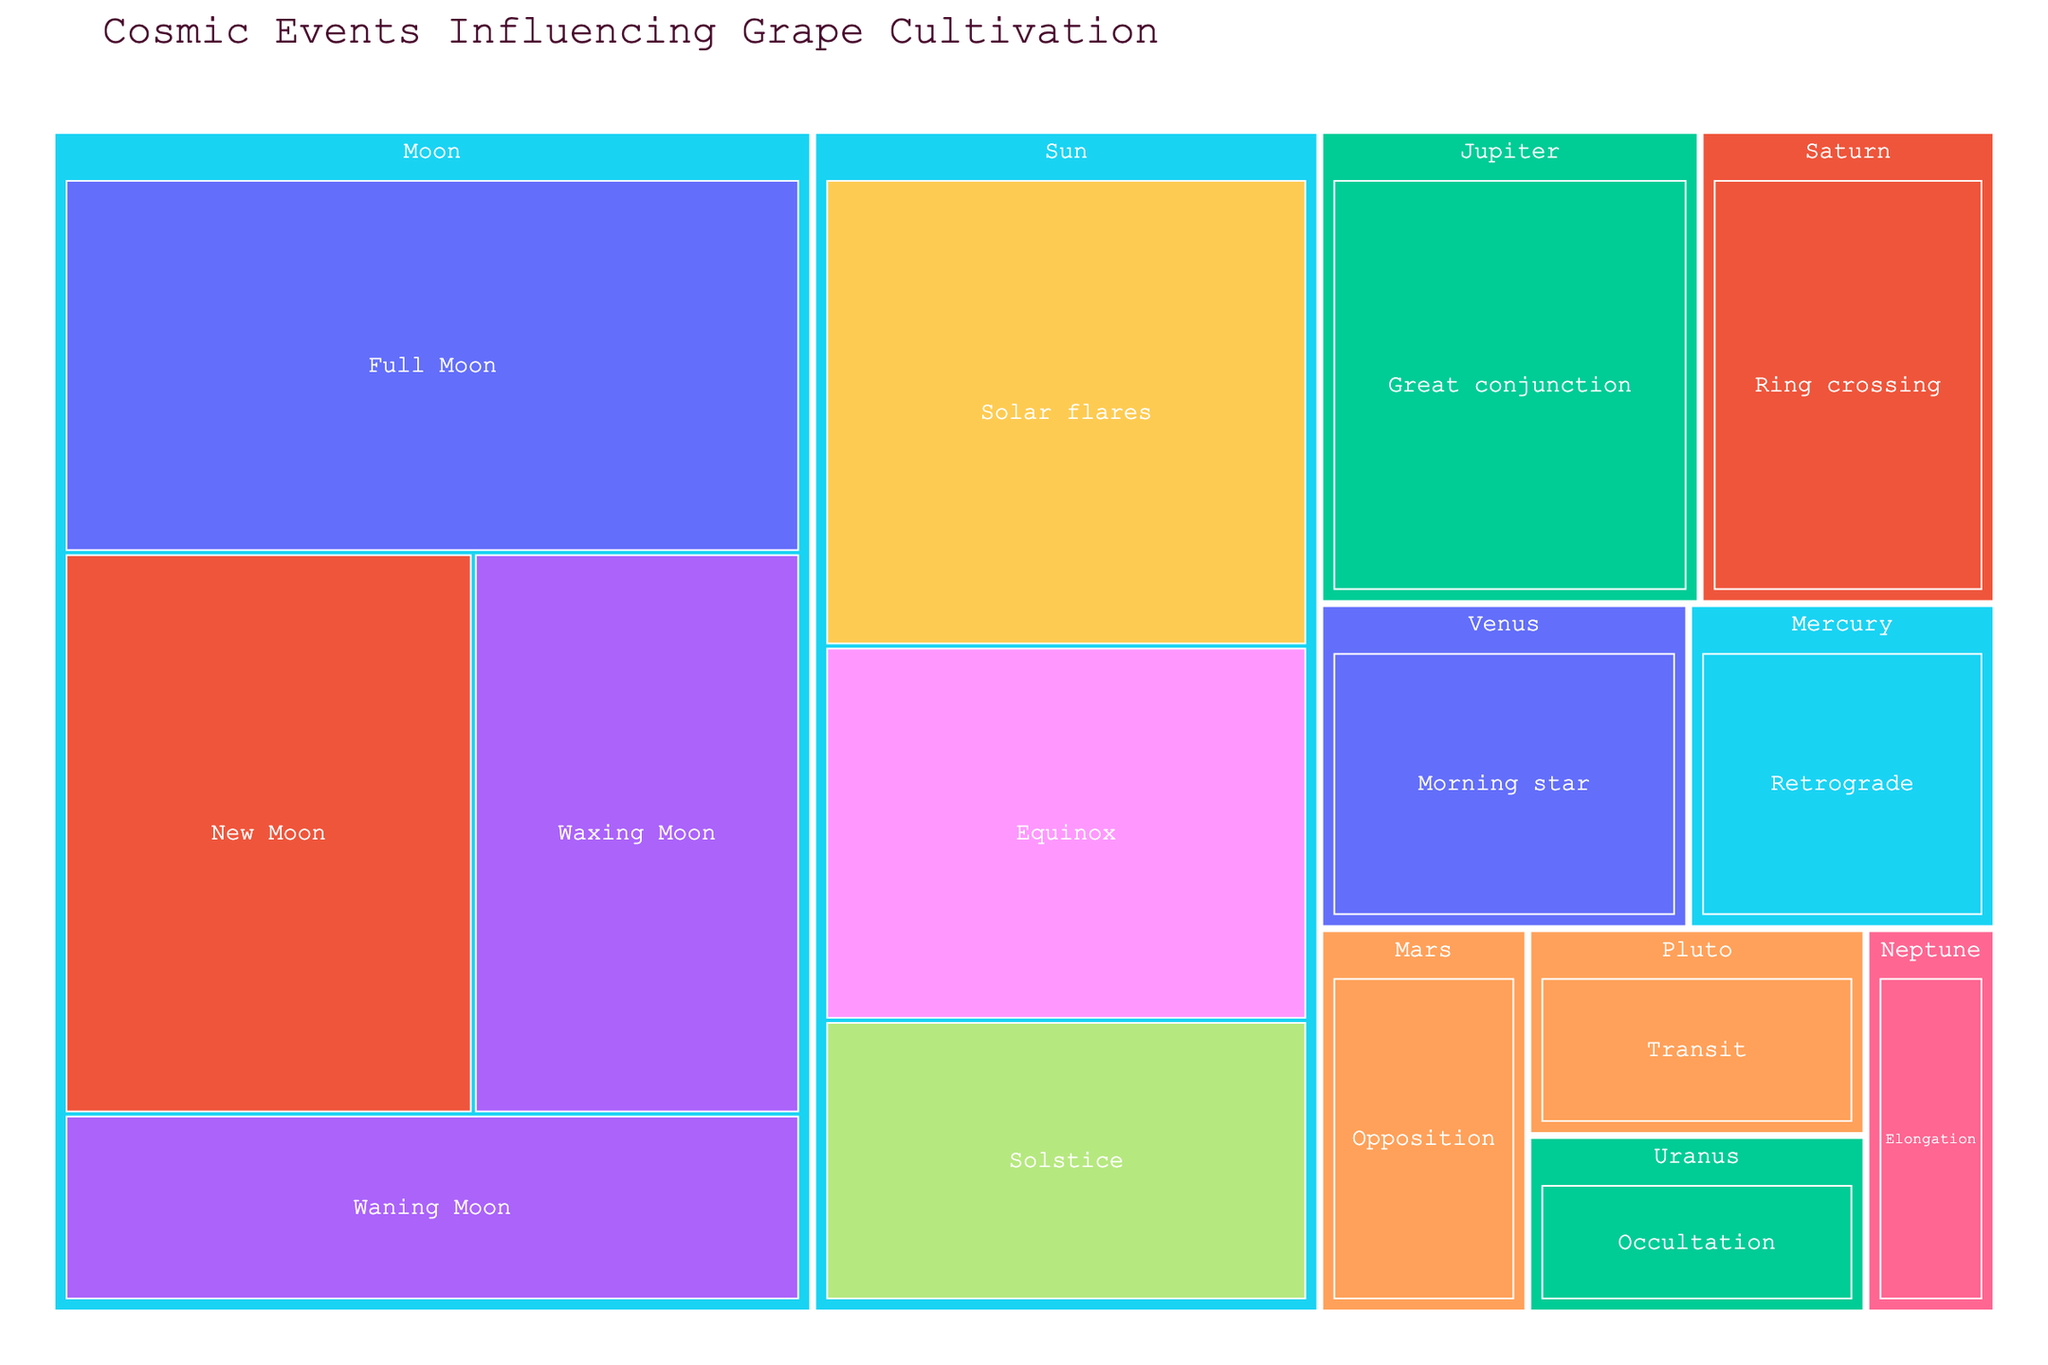What's the title of the figure? The title of the figure is located at the top and is designed to give an overview of what the plot is showing. By reading the title, you can understand that the plot is about "Cosmic Events Influencing Grape Cultivation".
Answer: Cosmic Events Influencing Grape Cultivation How many celestial bodies are represented in the plot? The treemap is organized by celestial bodies, so by counting the unique major sections in the plot, we can identify how many celestial bodies are represented.
Answer: 8 Which moon event has the highest perceived effect value? By examining the branches under the Moon section, we can compare the values associated with each event. The Full Moon has the highest value of 30 among the moon events.
Answer: Full Moon What is the combined value of events associated with the Sun? To find this, sum the values of the events under the Sun, which are Solar flares (25), Equinox (20), and Solstice (15). The combined value is 25 + 20 + 15 = 60.
Answer: 60 Which celestial body has the least perceived effect in grape cultivation? By checking the values for each celestial body and identifying the smallest value, we find that Neptune, with the Elongation event at a value of 5, has the least perceived effect.
Answer: Neptune Which perceived effect is linked to the Waxing Moon? By locating the Waxing Moon under the Moon section, the perceived effect associated with it is "Increased leaf development".
Answer: Increased leaf development What is the average value of the events associated with Mercury and Pluto combined? First, sum the values for Mercury (Retrograde: 10) and Pluto (Transit: 7). Then, compute the average by dividing the total value by the number of events (2). The average is (10 + 7) / 2 = 8.5.
Answer: 8.5 Which event has a higher value: Venus' Morning Star or Mars' Opposition? By comparing the values, we see that the value for Venus' Morning Star (12) is greater than the value for Mars' Opposition (8).
Answer: Venus' Morning Star What is the total value of all the events influenced by the Moon? Sum the values of all moon events: Full Moon (30), New Moon (25), Waxing Moon (20), and Waning Moon (15). The total value is 30 + 25 + 20 + 15 = 90.
Answer: 90 Which celestial body is associated with Enhanced aroma compounds? Checking the branches and labels associated with each celestial body, Enhanced aroma compounds are associated with Venus' Morning star.
Answer: Venus 